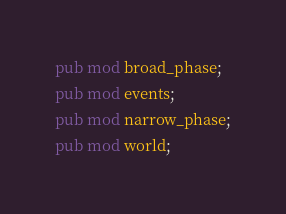Convert code to text. <code><loc_0><loc_0><loc_500><loc_500><_Rust_>
pub mod broad_phase;
pub mod events;
pub mod narrow_phase;
pub mod world;
</code> 